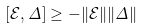Convert formula to latex. <formula><loc_0><loc_0><loc_500><loc_500>[ \mathcal { E } , \Delta ] \geq - \| \mathcal { E } \| \| \Delta \|</formula> 